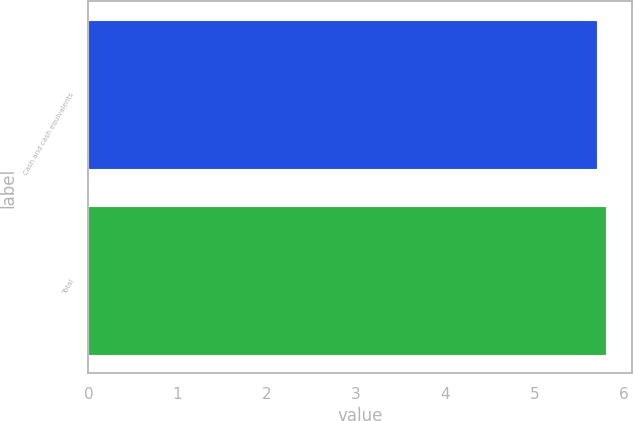Convert chart to OTSL. <chart><loc_0><loc_0><loc_500><loc_500><bar_chart><fcel>Cash and cash equivalents<fcel>Total<nl><fcel>5.7<fcel>5.8<nl></chart> 